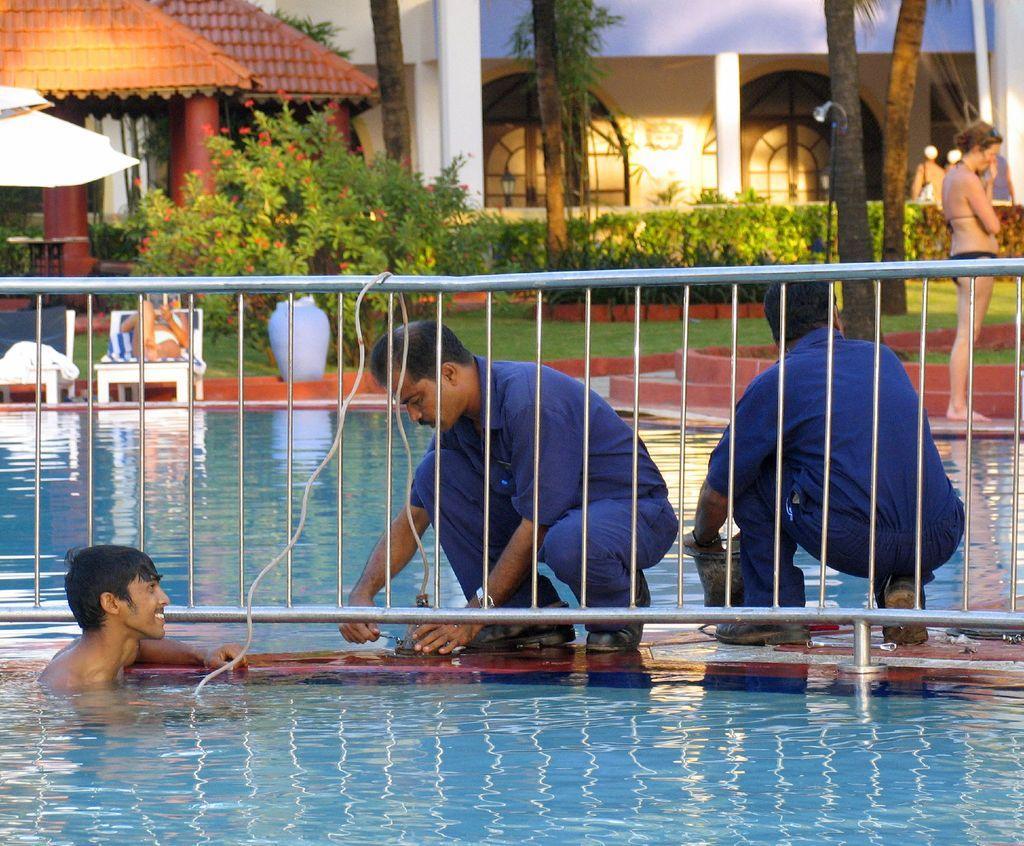Can you describe this image briefly? In the picture I can see two persons wearing blue dress are crouching and there is a fence beside them and there is a person standing in water in the left corner and there is are few trees,buildings and some other objects in the background and there is a woman standing in the right corner. 